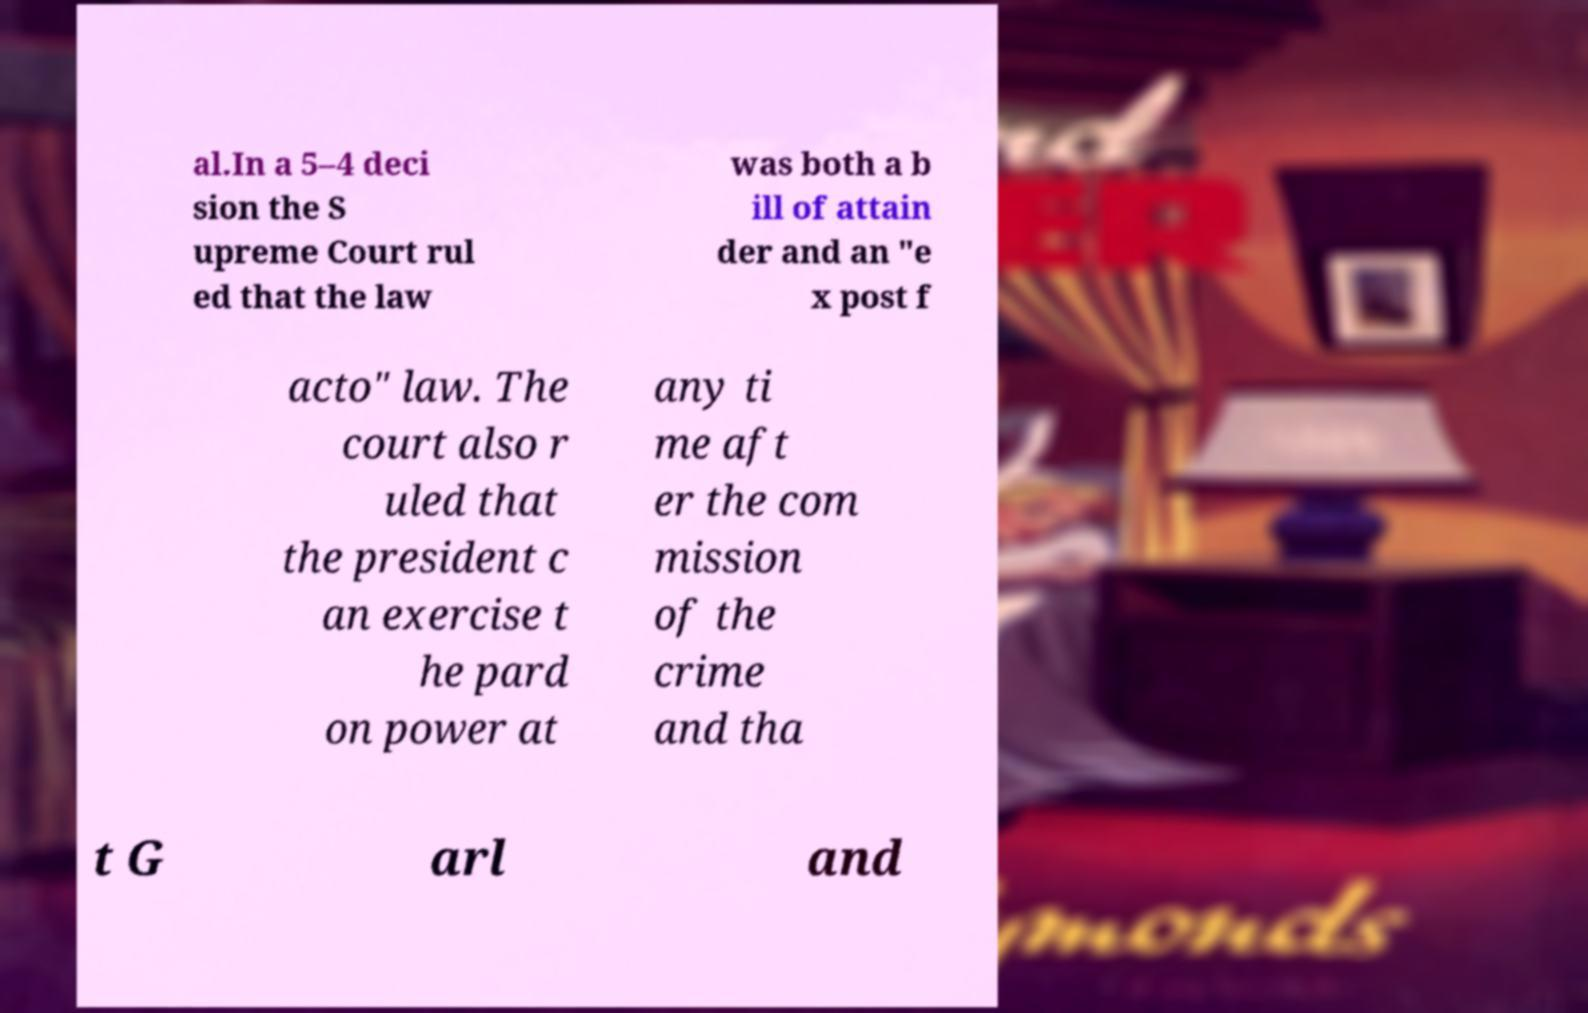For documentation purposes, I need the text within this image transcribed. Could you provide that? al.In a 5–4 deci sion the S upreme Court rul ed that the law was both a b ill of attain der and an "e x post f acto" law. The court also r uled that the president c an exercise t he pard on power at any ti me aft er the com mission of the crime and tha t G arl and 